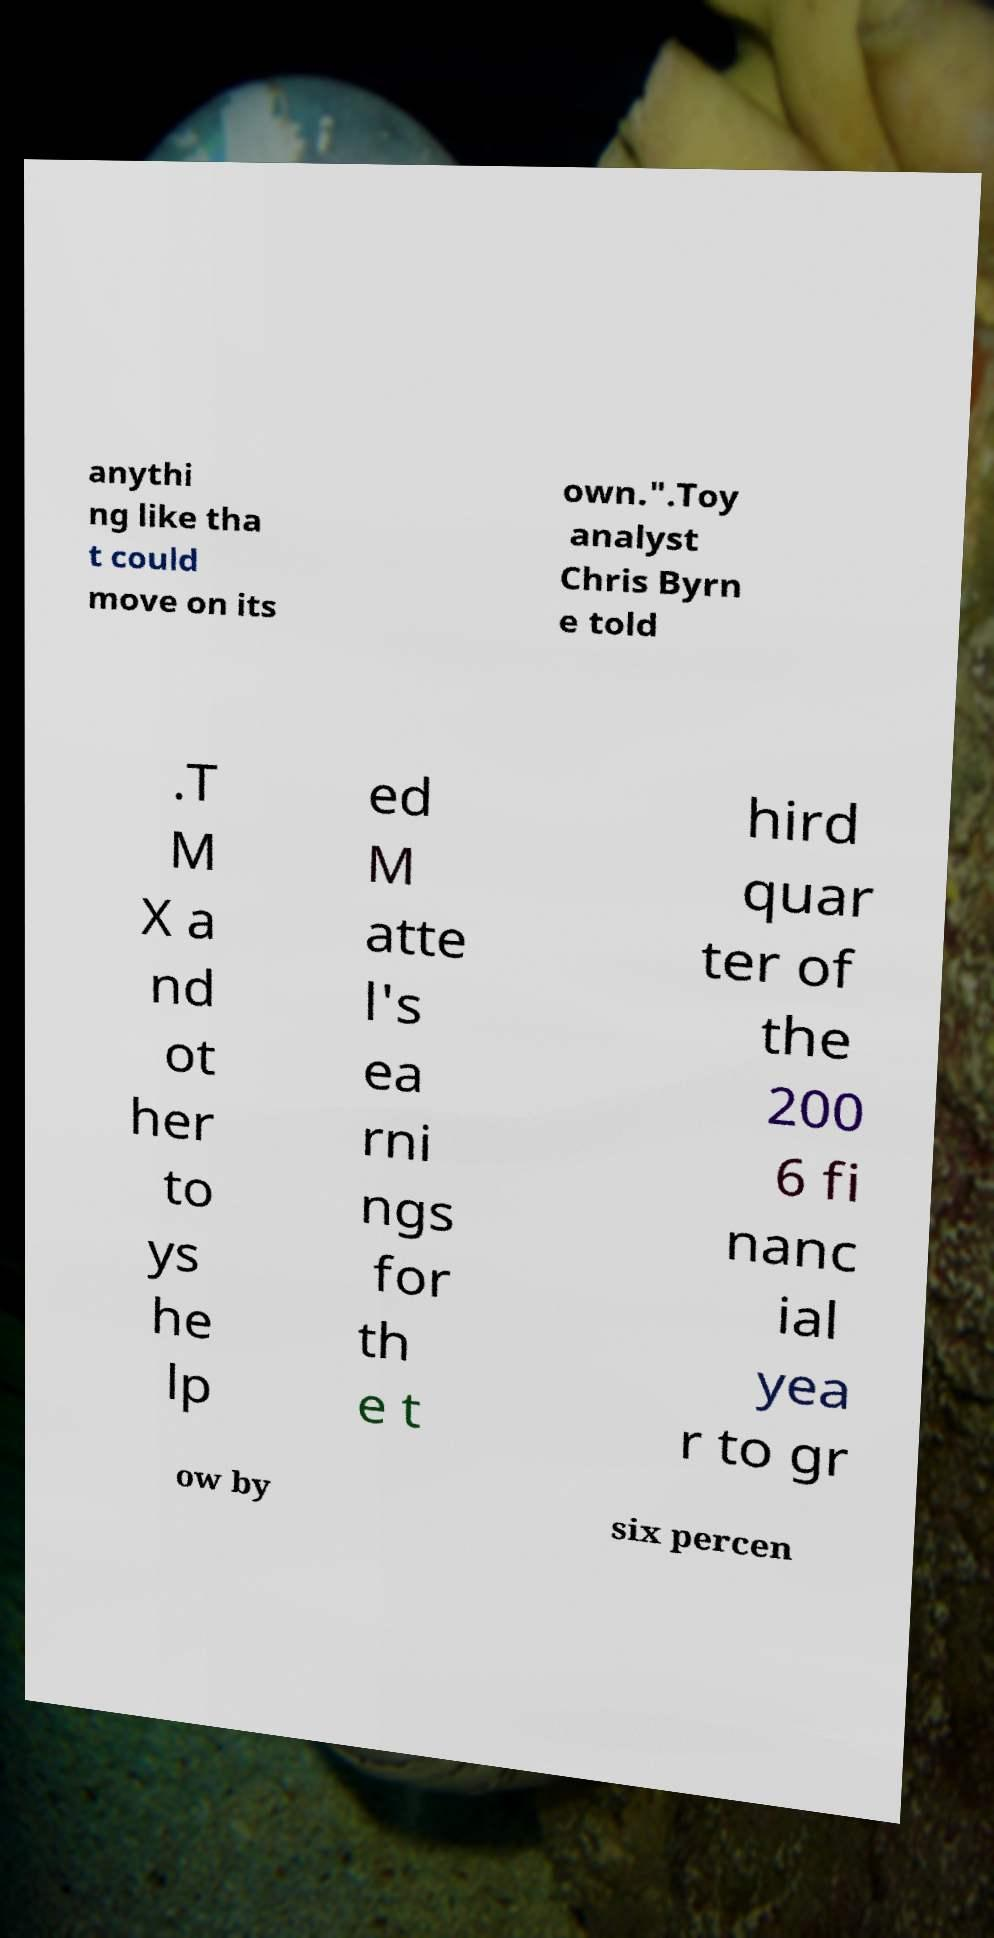Please read and relay the text visible in this image. What does it say? anythi ng like tha t could move on its own.".Toy analyst Chris Byrn e told .T M X a nd ot her to ys he lp ed M atte l's ea rni ngs for th e t hird quar ter of the 200 6 fi nanc ial yea r to gr ow by six percen 